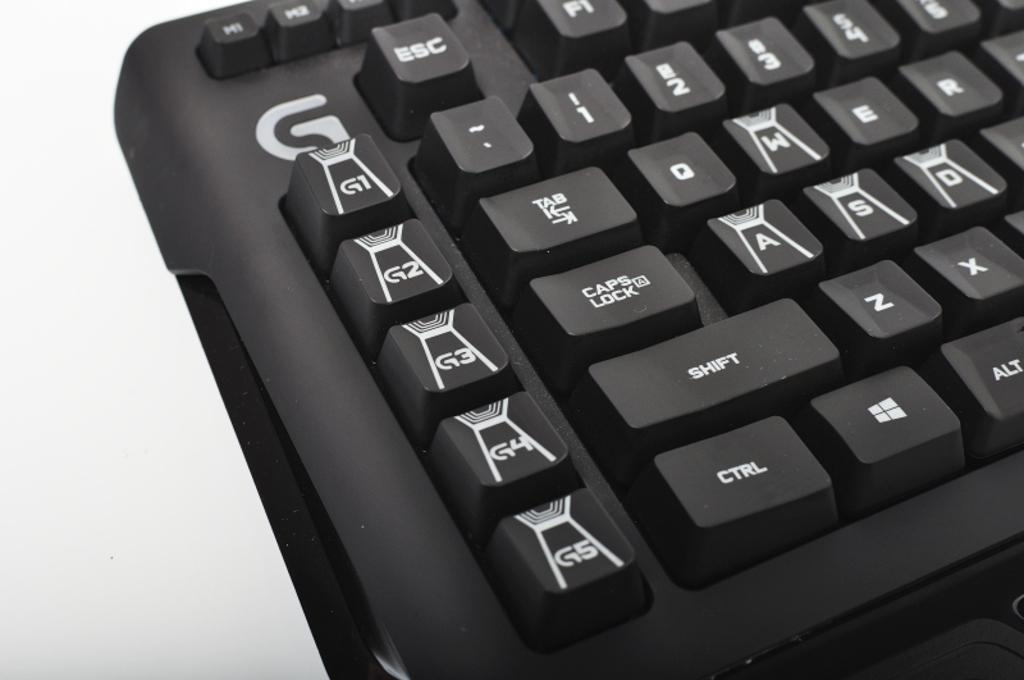<image>
Provide a brief description of the given image. A black keyboard with macro keys on the far left labeled G1-G5. 